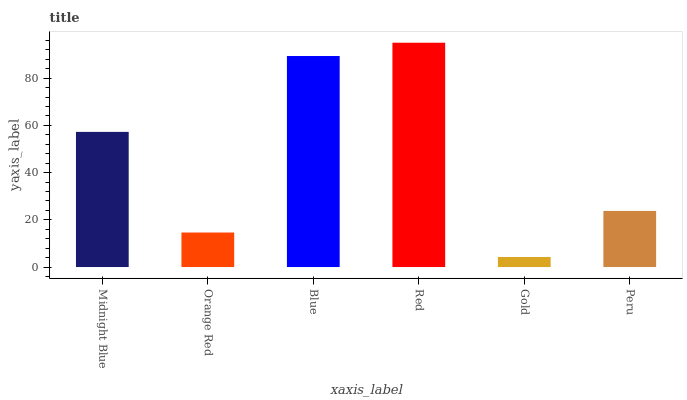Is Gold the minimum?
Answer yes or no. Yes. Is Red the maximum?
Answer yes or no. Yes. Is Orange Red the minimum?
Answer yes or no. No. Is Orange Red the maximum?
Answer yes or no. No. Is Midnight Blue greater than Orange Red?
Answer yes or no. Yes. Is Orange Red less than Midnight Blue?
Answer yes or no. Yes. Is Orange Red greater than Midnight Blue?
Answer yes or no. No. Is Midnight Blue less than Orange Red?
Answer yes or no. No. Is Midnight Blue the high median?
Answer yes or no. Yes. Is Peru the low median?
Answer yes or no. Yes. Is Blue the high median?
Answer yes or no. No. Is Midnight Blue the low median?
Answer yes or no. No. 